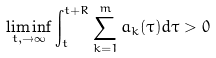Convert formula to latex. <formula><loc_0><loc_0><loc_500><loc_500>\liminf _ { t , \rightarrow \infty } \int _ { t } ^ { t + R } \sum _ { k = 1 } ^ { m } a _ { k } ( \tau ) d \tau > 0</formula> 